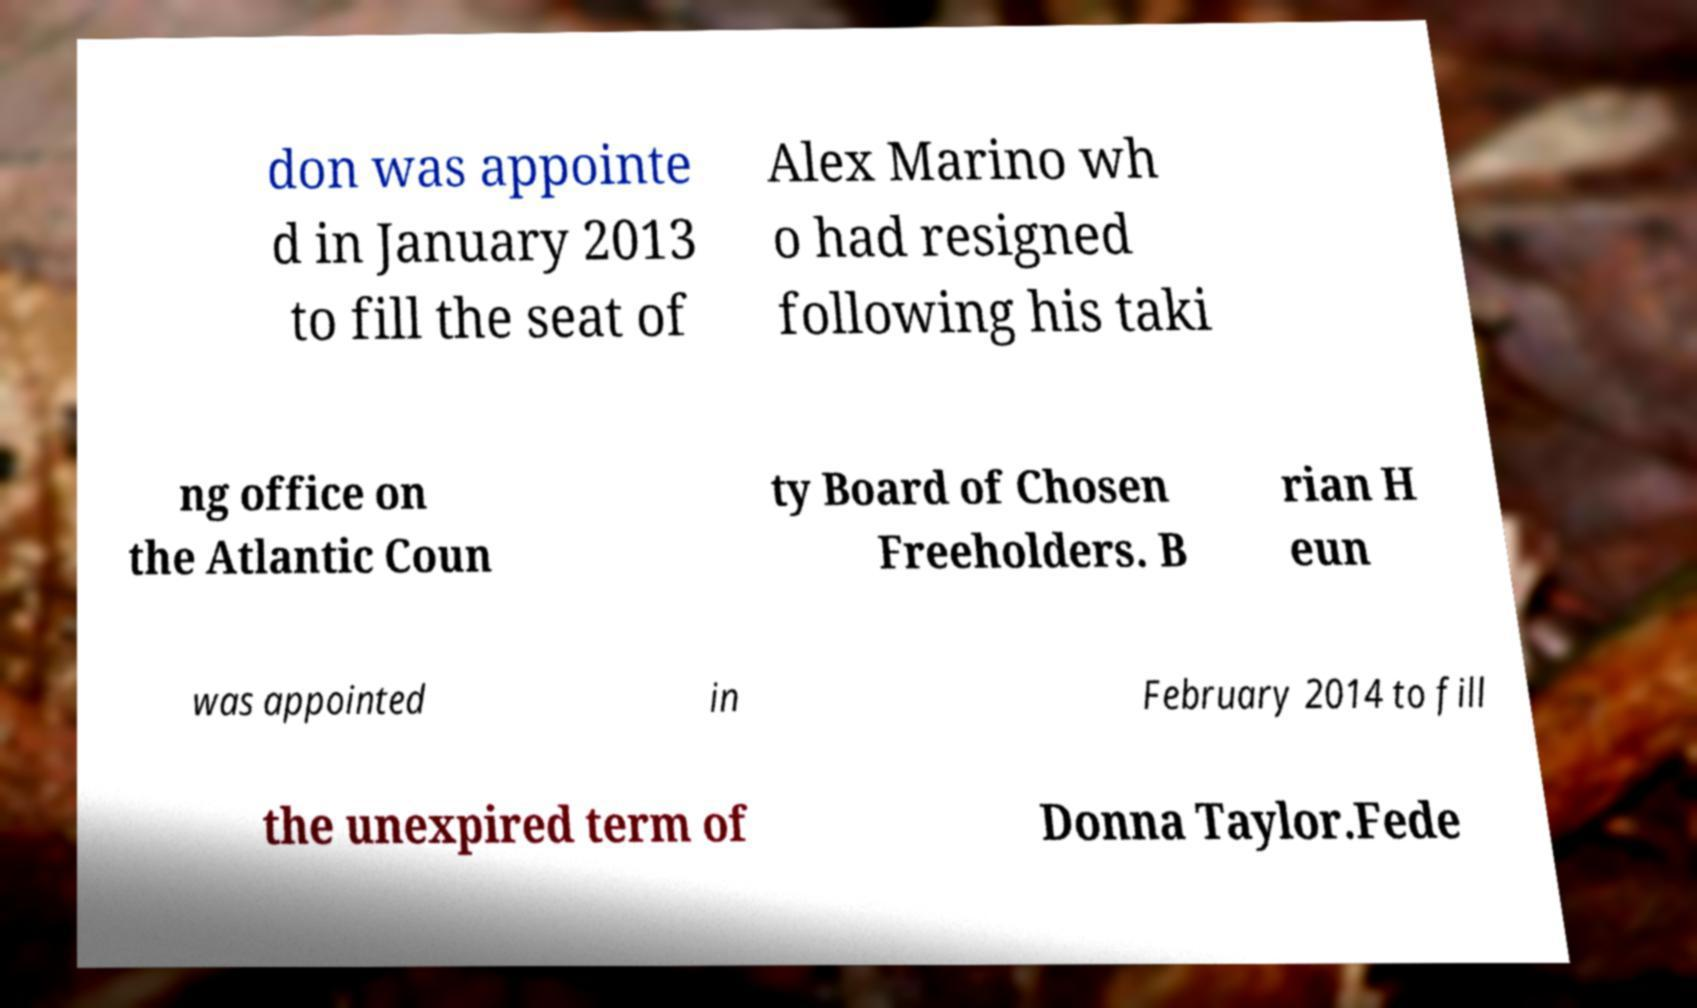Please identify and transcribe the text found in this image. don was appointe d in January 2013 to fill the seat of Alex Marino wh o had resigned following his taki ng office on the Atlantic Coun ty Board of Chosen Freeholders. B rian H eun was appointed in February 2014 to fill the unexpired term of Donna Taylor.Fede 